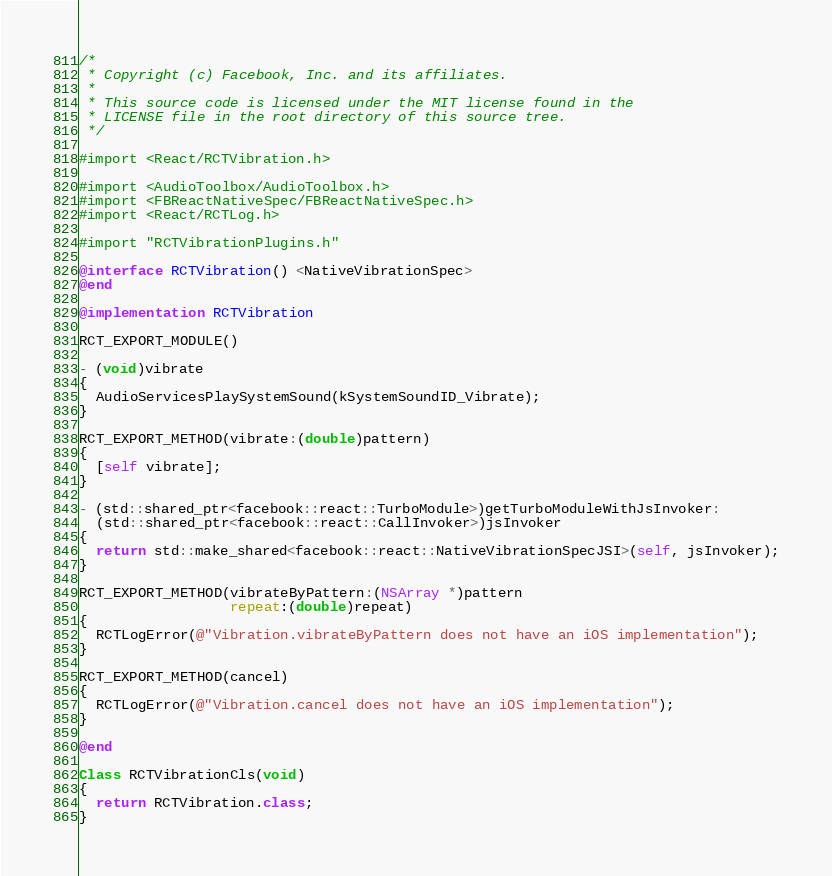Convert code to text. <code><loc_0><loc_0><loc_500><loc_500><_ObjectiveC_>/*
 * Copyright (c) Facebook, Inc. and its affiliates.
 *
 * This source code is licensed under the MIT license found in the
 * LICENSE file in the root directory of this source tree.
 */

#import <React/RCTVibration.h>

#import <AudioToolbox/AudioToolbox.h>
#import <FBReactNativeSpec/FBReactNativeSpec.h>
#import <React/RCTLog.h>

#import "RCTVibrationPlugins.h"

@interface RCTVibration() <NativeVibrationSpec>
@end

@implementation RCTVibration

RCT_EXPORT_MODULE()

- (void)vibrate
{
  AudioServicesPlaySystemSound(kSystemSoundID_Vibrate);
}

RCT_EXPORT_METHOD(vibrate:(double)pattern)
{
  [self vibrate];
}

- (std::shared_ptr<facebook::react::TurboModule>)getTurboModuleWithJsInvoker:
  (std::shared_ptr<facebook::react::CallInvoker>)jsInvoker
{
  return std::make_shared<facebook::react::NativeVibrationSpecJSI>(self, jsInvoker);
}

RCT_EXPORT_METHOD(vibrateByPattern:(NSArray *)pattern
                  repeat:(double)repeat)
{
  RCTLogError(@"Vibration.vibrateByPattern does not have an iOS implementation");
}

RCT_EXPORT_METHOD(cancel)
{
  RCTLogError(@"Vibration.cancel does not have an iOS implementation");
}

@end

Class RCTVibrationCls(void)
{
  return RCTVibration.class;
}
</code> 